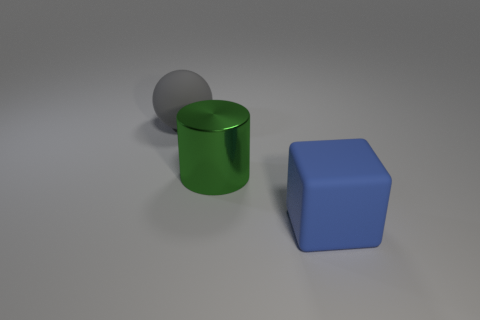Does the big thing to the left of the large cylinder have the same color as the large metallic object?
Your response must be concise. No. There is a large rubber object to the right of the large matte object behind the rubber cube; what shape is it?
Your response must be concise. Cube. Are there fewer large green metal things that are behind the metallic object than big balls behind the large gray rubber ball?
Provide a succinct answer. No. What number of objects are either matte objects left of the large rubber block or big things that are behind the big cylinder?
Provide a succinct answer. 1. Do the metal cylinder and the gray matte sphere have the same size?
Ensure brevity in your answer.  Yes. Is the number of large matte blocks greater than the number of large rubber objects?
Your answer should be very brief. No. How many other things are there of the same color as the metal thing?
Offer a very short reply. 0. What number of objects are green metal cylinders or matte objects?
Keep it short and to the point. 3. There is a matte thing that is in front of the matte sphere; is it the same shape as the shiny object?
Offer a terse response. No. The large matte thing behind the large matte thing in front of the large green cylinder is what color?
Keep it short and to the point. Gray. 